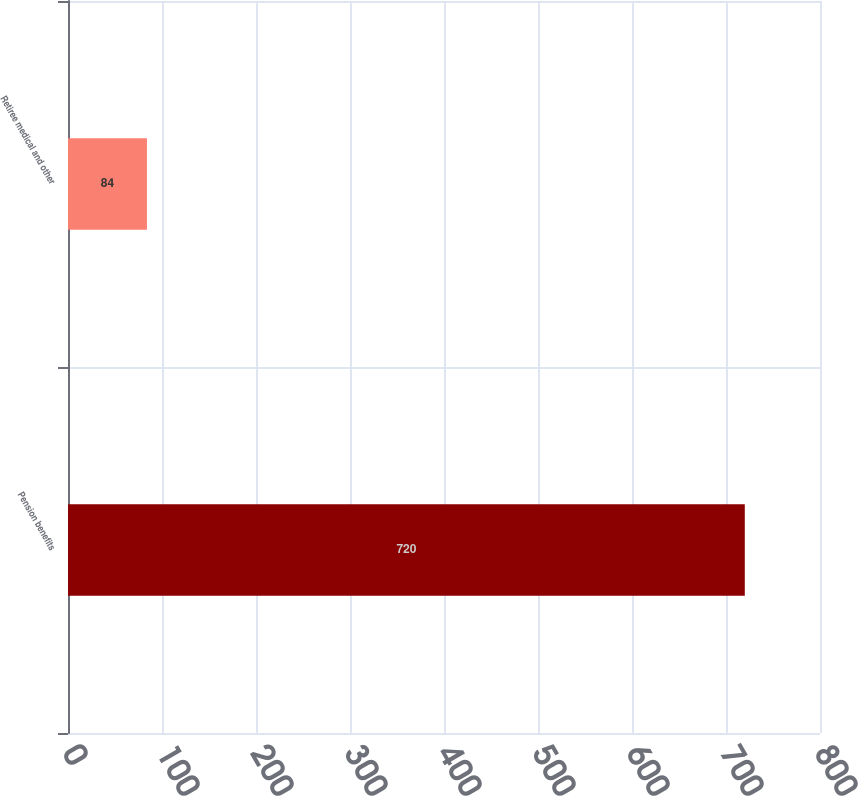Convert chart to OTSL. <chart><loc_0><loc_0><loc_500><loc_500><bar_chart><fcel>Pension benefits<fcel>Retiree medical and other<nl><fcel>720<fcel>84<nl></chart> 